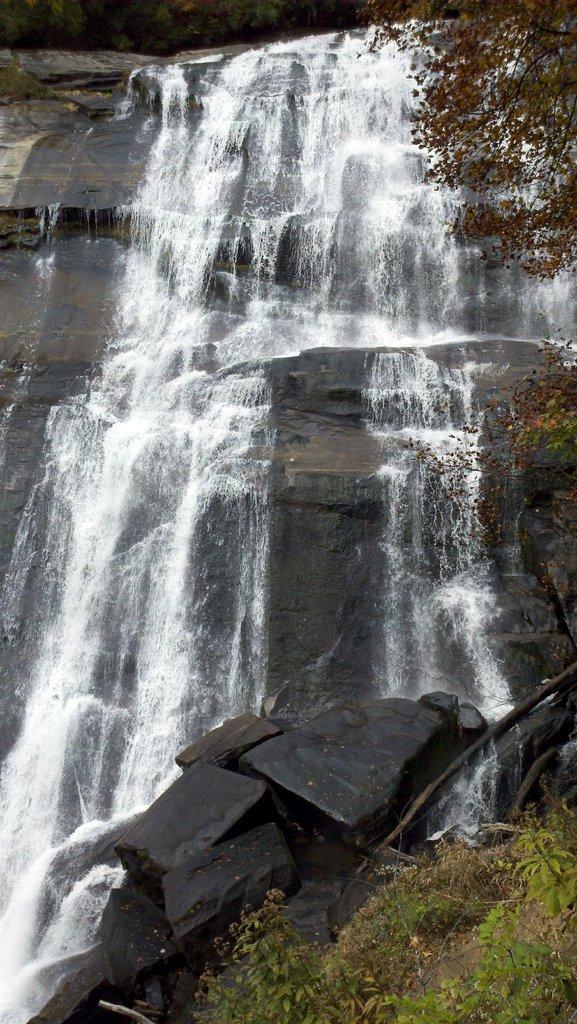Could you give a brief overview of what you see in this image? In this image I can see the waterfall. On the top, on the right and on the bottom side of this image I can see leaves. 